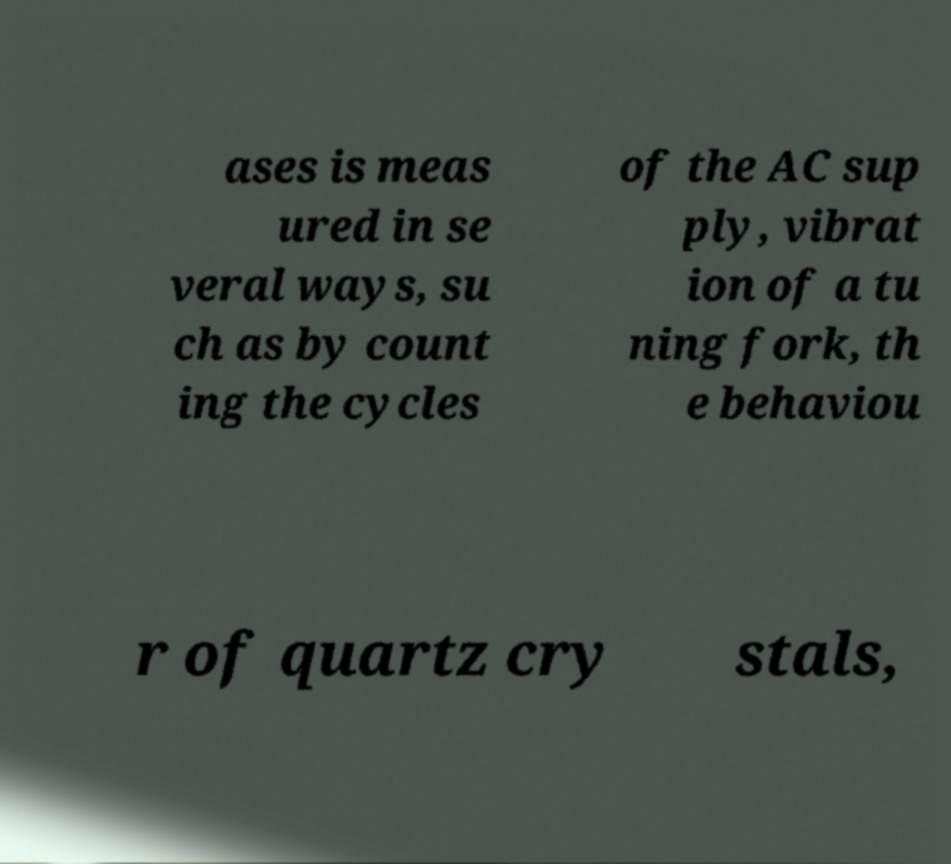There's text embedded in this image that I need extracted. Can you transcribe it verbatim? ases is meas ured in se veral ways, su ch as by count ing the cycles of the AC sup ply, vibrat ion of a tu ning fork, th e behaviou r of quartz cry stals, 